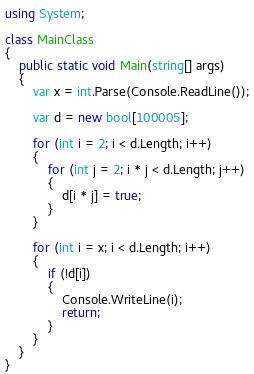<code> <loc_0><loc_0><loc_500><loc_500><_C#_>using System;

class MainClass
{
    public static void Main(string[] args)
    {
        var x = int.Parse(Console.ReadLine());

        var d = new bool[100005];

        for (int i = 2; i < d.Length; i++)
        {
            for (int j = 2; i * j < d.Length; j++)
            {
                d[i * j] = true;
            }
        }

        for (int i = x; i < d.Length; i++)
        {
            if (!d[i])
            {
                Console.WriteLine(i);
                return;
            }
        }
    }
}
</code> 